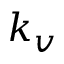Convert formula to latex. <formula><loc_0><loc_0><loc_500><loc_500>k _ { v }</formula> 